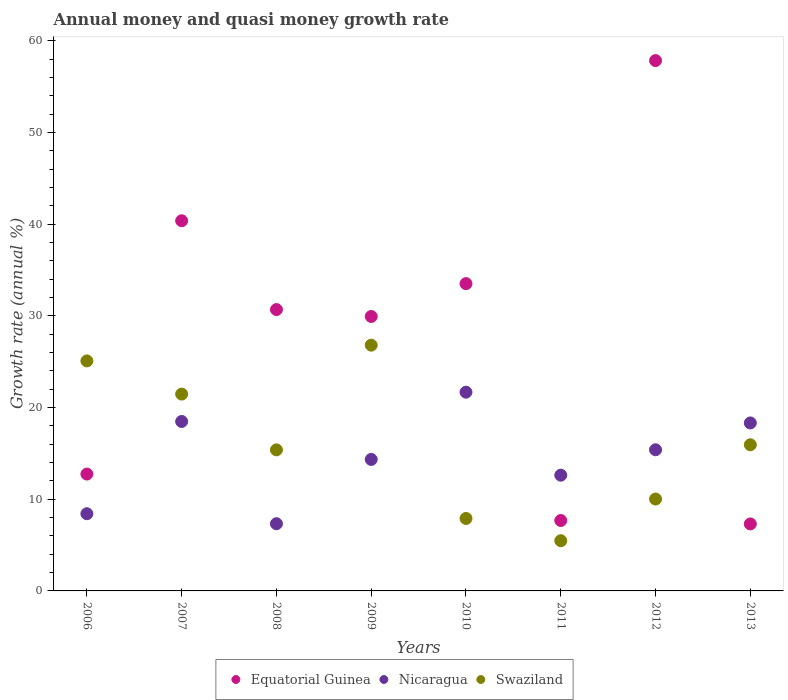What is the growth rate in Nicaragua in 2010?
Provide a short and direct response. 21.67. Across all years, what is the maximum growth rate in Swaziland?
Make the answer very short. 26.8. Across all years, what is the minimum growth rate in Equatorial Guinea?
Offer a terse response. 7.31. In which year was the growth rate in Swaziland maximum?
Your response must be concise. 2009. In which year was the growth rate in Swaziland minimum?
Give a very brief answer. 2011. What is the total growth rate in Nicaragua in the graph?
Offer a very short reply. 116.58. What is the difference between the growth rate in Equatorial Guinea in 2009 and that in 2012?
Give a very brief answer. -27.9. What is the difference between the growth rate in Nicaragua in 2006 and the growth rate in Equatorial Guinea in 2009?
Your answer should be compact. -21.51. What is the average growth rate in Equatorial Guinea per year?
Offer a terse response. 27.51. In the year 2012, what is the difference between the growth rate in Nicaragua and growth rate in Equatorial Guinea?
Provide a succinct answer. -42.44. What is the ratio of the growth rate in Nicaragua in 2006 to that in 2008?
Ensure brevity in your answer.  1.15. What is the difference between the highest and the second highest growth rate in Equatorial Guinea?
Offer a very short reply. 17.47. What is the difference between the highest and the lowest growth rate in Swaziland?
Provide a short and direct response. 21.33. Is it the case that in every year, the sum of the growth rate in Equatorial Guinea and growth rate in Nicaragua  is greater than the growth rate in Swaziland?
Offer a very short reply. No. Does the growth rate in Nicaragua monotonically increase over the years?
Offer a terse response. No. Is the growth rate in Equatorial Guinea strictly greater than the growth rate in Nicaragua over the years?
Provide a succinct answer. No. Is the growth rate in Equatorial Guinea strictly less than the growth rate in Swaziland over the years?
Provide a short and direct response. No. How many dotlines are there?
Offer a terse response. 3. How many years are there in the graph?
Provide a succinct answer. 8. What is the difference between two consecutive major ticks on the Y-axis?
Offer a very short reply. 10. Are the values on the major ticks of Y-axis written in scientific E-notation?
Ensure brevity in your answer.  No. How many legend labels are there?
Offer a very short reply. 3. How are the legend labels stacked?
Keep it short and to the point. Horizontal. What is the title of the graph?
Keep it short and to the point. Annual money and quasi money growth rate. Does "Low income" appear as one of the legend labels in the graph?
Keep it short and to the point. No. What is the label or title of the Y-axis?
Offer a terse response. Growth rate (annual %). What is the Growth rate (annual %) of Equatorial Guinea in 2006?
Your answer should be very brief. 12.74. What is the Growth rate (annual %) in Nicaragua in 2006?
Make the answer very short. 8.42. What is the Growth rate (annual %) of Swaziland in 2006?
Offer a very short reply. 25.08. What is the Growth rate (annual %) in Equatorial Guinea in 2007?
Provide a succinct answer. 40.37. What is the Growth rate (annual %) in Nicaragua in 2007?
Your answer should be compact. 18.48. What is the Growth rate (annual %) in Swaziland in 2007?
Your answer should be compact. 21.47. What is the Growth rate (annual %) of Equatorial Guinea in 2008?
Ensure brevity in your answer.  30.68. What is the Growth rate (annual %) of Nicaragua in 2008?
Give a very brief answer. 7.33. What is the Growth rate (annual %) of Swaziland in 2008?
Provide a short and direct response. 15.38. What is the Growth rate (annual %) of Equatorial Guinea in 2009?
Provide a short and direct response. 29.93. What is the Growth rate (annual %) of Nicaragua in 2009?
Give a very brief answer. 14.34. What is the Growth rate (annual %) in Swaziland in 2009?
Provide a short and direct response. 26.8. What is the Growth rate (annual %) of Equatorial Guinea in 2010?
Provide a short and direct response. 33.51. What is the Growth rate (annual %) of Nicaragua in 2010?
Ensure brevity in your answer.  21.67. What is the Growth rate (annual %) in Swaziland in 2010?
Ensure brevity in your answer.  7.9. What is the Growth rate (annual %) of Equatorial Guinea in 2011?
Ensure brevity in your answer.  7.68. What is the Growth rate (annual %) of Nicaragua in 2011?
Give a very brief answer. 12.62. What is the Growth rate (annual %) in Swaziland in 2011?
Your answer should be compact. 5.48. What is the Growth rate (annual %) in Equatorial Guinea in 2012?
Your answer should be compact. 57.83. What is the Growth rate (annual %) in Nicaragua in 2012?
Offer a very short reply. 15.39. What is the Growth rate (annual %) in Swaziland in 2012?
Make the answer very short. 10.02. What is the Growth rate (annual %) in Equatorial Guinea in 2013?
Your response must be concise. 7.31. What is the Growth rate (annual %) in Nicaragua in 2013?
Your response must be concise. 18.32. What is the Growth rate (annual %) in Swaziland in 2013?
Your answer should be compact. 15.94. Across all years, what is the maximum Growth rate (annual %) of Equatorial Guinea?
Ensure brevity in your answer.  57.83. Across all years, what is the maximum Growth rate (annual %) of Nicaragua?
Your answer should be compact. 21.67. Across all years, what is the maximum Growth rate (annual %) in Swaziland?
Keep it short and to the point. 26.8. Across all years, what is the minimum Growth rate (annual %) of Equatorial Guinea?
Keep it short and to the point. 7.31. Across all years, what is the minimum Growth rate (annual %) in Nicaragua?
Provide a succinct answer. 7.33. Across all years, what is the minimum Growth rate (annual %) in Swaziland?
Offer a terse response. 5.48. What is the total Growth rate (annual %) of Equatorial Guinea in the graph?
Keep it short and to the point. 220.05. What is the total Growth rate (annual %) of Nicaragua in the graph?
Ensure brevity in your answer.  116.58. What is the total Growth rate (annual %) of Swaziland in the graph?
Provide a short and direct response. 128.06. What is the difference between the Growth rate (annual %) in Equatorial Guinea in 2006 and that in 2007?
Make the answer very short. -27.62. What is the difference between the Growth rate (annual %) in Nicaragua in 2006 and that in 2007?
Your answer should be very brief. -10.06. What is the difference between the Growth rate (annual %) in Swaziland in 2006 and that in 2007?
Make the answer very short. 3.62. What is the difference between the Growth rate (annual %) of Equatorial Guinea in 2006 and that in 2008?
Make the answer very short. -17.94. What is the difference between the Growth rate (annual %) in Nicaragua in 2006 and that in 2008?
Provide a short and direct response. 1.09. What is the difference between the Growth rate (annual %) in Swaziland in 2006 and that in 2008?
Ensure brevity in your answer.  9.7. What is the difference between the Growth rate (annual %) in Equatorial Guinea in 2006 and that in 2009?
Ensure brevity in your answer.  -17.19. What is the difference between the Growth rate (annual %) of Nicaragua in 2006 and that in 2009?
Provide a short and direct response. -5.92. What is the difference between the Growth rate (annual %) of Swaziland in 2006 and that in 2009?
Your response must be concise. -1.72. What is the difference between the Growth rate (annual %) in Equatorial Guinea in 2006 and that in 2010?
Make the answer very short. -20.77. What is the difference between the Growth rate (annual %) of Nicaragua in 2006 and that in 2010?
Offer a very short reply. -13.25. What is the difference between the Growth rate (annual %) of Swaziland in 2006 and that in 2010?
Provide a succinct answer. 17.18. What is the difference between the Growth rate (annual %) in Equatorial Guinea in 2006 and that in 2011?
Offer a terse response. 5.06. What is the difference between the Growth rate (annual %) of Nicaragua in 2006 and that in 2011?
Ensure brevity in your answer.  -4.2. What is the difference between the Growth rate (annual %) of Swaziland in 2006 and that in 2011?
Provide a short and direct response. 19.61. What is the difference between the Growth rate (annual %) of Equatorial Guinea in 2006 and that in 2012?
Give a very brief answer. -45.09. What is the difference between the Growth rate (annual %) in Nicaragua in 2006 and that in 2012?
Give a very brief answer. -6.97. What is the difference between the Growth rate (annual %) of Swaziland in 2006 and that in 2012?
Provide a succinct answer. 15.07. What is the difference between the Growth rate (annual %) of Equatorial Guinea in 2006 and that in 2013?
Your response must be concise. 5.44. What is the difference between the Growth rate (annual %) of Nicaragua in 2006 and that in 2013?
Give a very brief answer. -9.9. What is the difference between the Growth rate (annual %) in Swaziland in 2006 and that in 2013?
Keep it short and to the point. 9.15. What is the difference between the Growth rate (annual %) of Equatorial Guinea in 2007 and that in 2008?
Offer a very short reply. 9.69. What is the difference between the Growth rate (annual %) in Nicaragua in 2007 and that in 2008?
Provide a succinct answer. 11.15. What is the difference between the Growth rate (annual %) in Swaziland in 2007 and that in 2008?
Offer a very short reply. 6.08. What is the difference between the Growth rate (annual %) in Equatorial Guinea in 2007 and that in 2009?
Keep it short and to the point. 10.44. What is the difference between the Growth rate (annual %) in Nicaragua in 2007 and that in 2009?
Offer a terse response. 4.14. What is the difference between the Growth rate (annual %) of Swaziland in 2007 and that in 2009?
Keep it short and to the point. -5.34. What is the difference between the Growth rate (annual %) in Equatorial Guinea in 2007 and that in 2010?
Keep it short and to the point. 6.86. What is the difference between the Growth rate (annual %) in Nicaragua in 2007 and that in 2010?
Offer a terse response. -3.19. What is the difference between the Growth rate (annual %) of Swaziland in 2007 and that in 2010?
Offer a very short reply. 13.56. What is the difference between the Growth rate (annual %) in Equatorial Guinea in 2007 and that in 2011?
Give a very brief answer. 32.69. What is the difference between the Growth rate (annual %) in Nicaragua in 2007 and that in 2011?
Your answer should be very brief. 5.86. What is the difference between the Growth rate (annual %) in Swaziland in 2007 and that in 2011?
Provide a succinct answer. 15.99. What is the difference between the Growth rate (annual %) of Equatorial Guinea in 2007 and that in 2012?
Your answer should be very brief. -17.47. What is the difference between the Growth rate (annual %) of Nicaragua in 2007 and that in 2012?
Give a very brief answer. 3.09. What is the difference between the Growth rate (annual %) in Swaziland in 2007 and that in 2012?
Your answer should be compact. 11.45. What is the difference between the Growth rate (annual %) of Equatorial Guinea in 2007 and that in 2013?
Make the answer very short. 33.06. What is the difference between the Growth rate (annual %) in Nicaragua in 2007 and that in 2013?
Provide a short and direct response. 0.16. What is the difference between the Growth rate (annual %) in Swaziland in 2007 and that in 2013?
Your answer should be very brief. 5.53. What is the difference between the Growth rate (annual %) in Equatorial Guinea in 2008 and that in 2009?
Ensure brevity in your answer.  0.75. What is the difference between the Growth rate (annual %) of Nicaragua in 2008 and that in 2009?
Offer a very short reply. -7.01. What is the difference between the Growth rate (annual %) in Swaziland in 2008 and that in 2009?
Provide a succinct answer. -11.42. What is the difference between the Growth rate (annual %) in Equatorial Guinea in 2008 and that in 2010?
Offer a terse response. -2.83. What is the difference between the Growth rate (annual %) of Nicaragua in 2008 and that in 2010?
Give a very brief answer. -14.34. What is the difference between the Growth rate (annual %) in Swaziland in 2008 and that in 2010?
Provide a succinct answer. 7.48. What is the difference between the Growth rate (annual %) in Equatorial Guinea in 2008 and that in 2011?
Provide a succinct answer. 23. What is the difference between the Growth rate (annual %) of Nicaragua in 2008 and that in 2011?
Provide a short and direct response. -5.29. What is the difference between the Growth rate (annual %) in Swaziland in 2008 and that in 2011?
Your answer should be compact. 9.91. What is the difference between the Growth rate (annual %) of Equatorial Guinea in 2008 and that in 2012?
Your answer should be compact. -27.15. What is the difference between the Growth rate (annual %) in Nicaragua in 2008 and that in 2012?
Provide a short and direct response. -8.06. What is the difference between the Growth rate (annual %) in Swaziland in 2008 and that in 2012?
Your response must be concise. 5.37. What is the difference between the Growth rate (annual %) of Equatorial Guinea in 2008 and that in 2013?
Your answer should be compact. 23.37. What is the difference between the Growth rate (annual %) in Nicaragua in 2008 and that in 2013?
Give a very brief answer. -10.99. What is the difference between the Growth rate (annual %) of Swaziland in 2008 and that in 2013?
Ensure brevity in your answer.  -0.55. What is the difference between the Growth rate (annual %) of Equatorial Guinea in 2009 and that in 2010?
Give a very brief answer. -3.58. What is the difference between the Growth rate (annual %) of Nicaragua in 2009 and that in 2010?
Offer a terse response. -7.33. What is the difference between the Growth rate (annual %) in Swaziland in 2009 and that in 2010?
Make the answer very short. 18.9. What is the difference between the Growth rate (annual %) in Equatorial Guinea in 2009 and that in 2011?
Your response must be concise. 22.25. What is the difference between the Growth rate (annual %) of Nicaragua in 2009 and that in 2011?
Give a very brief answer. 1.72. What is the difference between the Growth rate (annual %) in Swaziland in 2009 and that in 2011?
Your answer should be very brief. 21.33. What is the difference between the Growth rate (annual %) of Equatorial Guinea in 2009 and that in 2012?
Make the answer very short. -27.9. What is the difference between the Growth rate (annual %) of Nicaragua in 2009 and that in 2012?
Give a very brief answer. -1.05. What is the difference between the Growth rate (annual %) in Swaziland in 2009 and that in 2012?
Give a very brief answer. 16.78. What is the difference between the Growth rate (annual %) of Equatorial Guinea in 2009 and that in 2013?
Make the answer very short. 22.62. What is the difference between the Growth rate (annual %) in Nicaragua in 2009 and that in 2013?
Keep it short and to the point. -3.98. What is the difference between the Growth rate (annual %) of Swaziland in 2009 and that in 2013?
Your answer should be compact. 10.86. What is the difference between the Growth rate (annual %) of Equatorial Guinea in 2010 and that in 2011?
Offer a terse response. 25.83. What is the difference between the Growth rate (annual %) in Nicaragua in 2010 and that in 2011?
Provide a short and direct response. 9.05. What is the difference between the Growth rate (annual %) in Swaziland in 2010 and that in 2011?
Your answer should be compact. 2.43. What is the difference between the Growth rate (annual %) of Equatorial Guinea in 2010 and that in 2012?
Your response must be concise. -24.32. What is the difference between the Growth rate (annual %) in Nicaragua in 2010 and that in 2012?
Your answer should be compact. 6.28. What is the difference between the Growth rate (annual %) of Swaziland in 2010 and that in 2012?
Ensure brevity in your answer.  -2.12. What is the difference between the Growth rate (annual %) of Equatorial Guinea in 2010 and that in 2013?
Offer a terse response. 26.2. What is the difference between the Growth rate (annual %) of Nicaragua in 2010 and that in 2013?
Offer a terse response. 3.35. What is the difference between the Growth rate (annual %) of Swaziland in 2010 and that in 2013?
Ensure brevity in your answer.  -8.03. What is the difference between the Growth rate (annual %) of Equatorial Guinea in 2011 and that in 2012?
Give a very brief answer. -50.15. What is the difference between the Growth rate (annual %) in Nicaragua in 2011 and that in 2012?
Your answer should be compact. -2.77. What is the difference between the Growth rate (annual %) of Swaziland in 2011 and that in 2012?
Your answer should be compact. -4.54. What is the difference between the Growth rate (annual %) of Equatorial Guinea in 2011 and that in 2013?
Your answer should be very brief. 0.37. What is the difference between the Growth rate (annual %) in Nicaragua in 2011 and that in 2013?
Your answer should be very brief. -5.7. What is the difference between the Growth rate (annual %) in Swaziland in 2011 and that in 2013?
Your answer should be very brief. -10.46. What is the difference between the Growth rate (annual %) of Equatorial Guinea in 2012 and that in 2013?
Keep it short and to the point. 50.53. What is the difference between the Growth rate (annual %) in Nicaragua in 2012 and that in 2013?
Keep it short and to the point. -2.93. What is the difference between the Growth rate (annual %) in Swaziland in 2012 and that in 2013?
Offer a very short reply. -5.92. What is the difference between the Growth rate (annual %) of Equatorial Guinea in 2006 and the Growth rate (annual %) of Nicaragua in 2007?
Your response must be concise. -5.74. What is the difference between the Growth rate (annual %) of Equatorial Guinea in 2006 and the Growth rate (annual %) of Swaziland in 2007?
Give a very brief answer. -8.72. What is the difference between the Growth rate (annual %) in Nicaragua in 2006 and the Growth rate (annual %) in Swaziland in 2007?
Your answer should be compact. -13.05. What is the difference between the Growth rate (annual %) of Equatorial Guinea in 2006 and the Growth rate (annual %) of Nicaragua in 2008?
Make the answer very short. 5.41. What is the difference between the Growth rate (annual %) in Equatorial Guinea in 2006 and the Growth rate (annual %) in Swaziland in 2008?
Ensure brevity in your answer.  -2.64. What is the difference between the Growth rate (annual %) of Nicaragua in 2006 and the Growth rate (annual %) of Swaziland in 2008?
Your answer should be compact. -6.96. What is the difference between the Growth rate (annual %) of Equatorial Guinea in 2006 and the Growth rate (annual %) of Nicaragua in 2009?
Keep it short and to the point. -1.59. What is the difference between the Growth rate (annual %) in Equatorial Guinea in 2006 and the Growth rate (annual %) in Swaziland in 2009?
Your answer should be very brief. -14.06. What is the difference between the Growth rate (annual %) in Nicaragua in 2006 and the Growth rate (annual %) in Swaziland in 2009?
Keep it short and to the point. -18.38. What is the difference between the Growth rate (annual %) of Equatorial Guinea in 2006 and the Growth rate (annual %) of Nicaragua in 2010?
Provide a succinct answer. -8.93. What is the difference between the Growth rate (annual %) in Equatorial Guinea in 2006 and the Growth rate (annual %) in Swaziland in 2010?
Ensure brevity in your answer.  4.84. What is the difference between the Growth rate (annual %) in Nicaragua in 2006 and the Growth rate (annual %) in Swaziland in 2010?
Ensure brevity in your answer.  0.52. What is the difference between the Growth rate (annual %) of Equatorial Guinea in 2006 and the Growth rate (annual %) of Nicaragua in 2011?
Your answer should be compact. 0.12. What is the difference between the Growth rate (annual %) of Equatorial Guinea in 2006 and the Growth rate (annual %) of Swaziland in 2011?
Your answer should be very brief. 7.27. What is the difference between the Growth rate (annual %) in Nicaragua in 2006 and the Growth rate (annual %) in Swaziland in 2011?
Provide a short and direct response. 2.95. What is the difference between the Growth rate (annual %) in Equatorial Guinea in 2006 and the Growth rate (annual %) in Nicaragua in 2012?
Provide a succinct answer. -2.65. What is the difference between the Growth rate (annual %) of Equatorial Guinea in 2006 and the Growth rate (annual %) of Swaziland in 2012?
Provide a short and direct response. 2.73. What is the difference between the Growth rate (annual %) in Nicaragua in 2006 and the Growth rate (annual %) in Swaziland in 2012?
Keep it short and to the point. -1.6. What is the difference between the Growth rate (annual %) in Equatorial Guinea in 2006 and the Growth rate (annual %) in Nicaragua in 2013?
Keep it short and to the point. -5.58. What is the difference between the Growth rate (annual %) in Equatorial Guinea in 2006 and the Growth rate (annual %) in Swaziland in 2013?
Provide a short and direct response. -3.19. What is the difference between the Growth rate (annual %) of Nicaragua in 2006 and the Growth rate (annual %) of Swaziland in 2013?
Your answer should be very brief. -7.52. What is the difference between the Growth rate (annual %) in Equatorial Guinea in 2007 and the Growth rate (annual %) in Nicaragua in 2008?
Your answer should be compact. 33.04. What is the difference between the Growth rate (annual %) of Equatorial Guinea in 2007 and the Growth rate (annual %) of Swaziland in 2008?
Give a very brief answer. 24.98. What is the difference between the Growth rate (annual %) of Nicaragua in 2007 and the Growth rate (annual %) of Swaziland in 2008?
Ensure brevity in your answer.  3.1. What is the difference between the Growth rate (annual %) of Equatorial Guinea in 2007 and the Growth rate (annual %) of Nicaragua in 2009?
Provide a succinct answer. 26.03. What is the difference between the Growth rate (annual %) in Equatorial Guinea in 2007 and the Growth rate (annual %) in Swaziland in 2009?
Make the answer very short. 13.57. What is the difference between the Growth rate (annual %) of Nicaragua in 2007 and the Growth rate (annual %) of Swaziland in 2009?
Keep it short and to the point. -8.32. What is the difference between the Growth rate (annual %) in Equatorial Guinea in 2007 and the Growth rate (annual %) in Nicaragua in 2010?
Provide a succinct answer. 18.69. What is the difference between the Growth rate (annual %) in Equatorial Guinea in 2007 and the Growth rate (annual %) in Swaziland in 2010?
Ensure brevity in your answer.  32.47. What is the difference between the Growth rate (annual %) in Nicaragua in 2007 and the Growth rate (annual %) in Swaziland in 2010?
Keep it short and to the point. 10.58. What is the difference between the Growth rate (annual %) in Equatorial Guinea in 2007 and the Growth rate (annual %) in Nicaragua in 2011?
Provide a short and direct response. 27.75. What is the difference between the Growth rate (annual %) in Equatorial Guinea in 2007 and the Growth rate (annual %) in Swaziland in 2011?
Your answer should be very brief. 34.89. What is the difference between the Growth rate (annual %) of Nicaragua in 2007 and the Growth rate (annual %) of Swaziland in 2011?
Your answer should be very brief. 13. What is the difference between the Growth rate (annual %) in Equatorial Guinea in 2007 and the Growth rate (annual %) in Nicaragua in 2012?
Your response must be concise. 24.97. What is the difference between the Growth rate (annual %) of Equatorial Guinea in 2007 and the Growth rate (annual %) of Swaziland in 2012?
Provide a short and direct response. 30.35. What is the difference between the Growth rate (annual %) in Nicaragua in 2007 and the Growth rate (annual %) in Swaziland in 2012?
Your answer should be very brief. 8.46. What is the difference between the Growth rate (annual %) in Equatorial Guinea in 2007 and the Growth rate (annual %) in Nicaragua in 2013?
Make the answer very short. 22.05. What is the difference between the Growth rate (annual %) of Equatorial Guinea in 2007 and the Growth rate (annual %) of Swaziland in 2013?
Keep it short and to the point. 24.43. What is the difference between the Growth rate (annual %) of Nicaragua in 2007 and the Growth rate (annual %) of Swaziland in 2013?
Keep it short and to the point. 2.54. What is the difference between the Growth rate (annual %) in Equatorial Guinea in 2008 and the Growth rate (annual %) in Nicaragua in 2009?
Make the answer very short. 16.34. What is the difference between the Growth rate (annual %) of Equatorial Guinea in 2008 and the Growth rate (annual %) of Swaziland in 2009?
Offer a terse response. 3.88. What is the difference between the Growth rate (annual %) of Nicaragua in 2008 and the Growth rate (annual %) of Swaziland in 2009?
Give a very brief answer. -19.47. What is the difference between the Growth rate (annual %) in Equatorial Guinea in 2008 and the Growth rate (annual %) in Nicaragua in 2010?
Provide a succinct answer. 9.01. What is the difference between the Growth rate (annual %) in Equatorial Guinea in 2008 and the Growth rate (annual %) in Swaziland in 2010?
Provide a succinct answer. 22.78. What is the difference between the Growth rate (annual %) of Nicaragua in 2008 and the Growth rate (annual %) of Swaziland in 2010?
Keep it short and to the point. -0.57. What is the difference between the Growth rate (annual %) of Equatorial Guinea in 2008 and the Growth rate (annual %) of Nicaragua in 2011?
Your answer should be very brief. 18.06. What is the difference between the Growth rate (annual %) of Equatorial Guinea in 2008 and the Growth rate (annual %) of Swaziland in 2011?
Ensure brevity in your answer.  25.2. What is the difference between the Growth rate (annual %) of Nicaragua in 2008 and the Growth rate (annual %) of Swaziland in 2011?
Offer a terse response. 1.85. What is the difference between the Growth rate (annual %) of Equatorial Guinea in 2008 and the Growth rate (annual %) of Nicaragua in 2012?
Keep it short and to the point. 15.29. What is the difference between the Growth rate (annual %) of Equatorial Guinea in 2008 and the Growth rate (annual %) of Swaziland in 2012?
Your answer should be compact. 20.66. What is the difference between the Growth rate (annual %) in Nicaragua in 2008 and the Growth rate (annual %) in Swaziland in 2012?
Give a very brief answer. -2.69. What is the difference between the Growth rate (annual %) in Equatorial Guinea in 2008 and the Growth rate (annual %) in Nicaragua in 2013?
Ensure brevity in your answer.  12.36. What is the difference between the Growth rate (annual %) of Equatorial Guinea in 2008 and the Growth rate (annual %) of Swaziland in 2013?
Offer a terse response. 14.74. What is the difference between the Growth rate (annual %) of Nicaragua in 2008 and the Growth rate (annual %) of Swaziland in 2013?
Make the answer very short. -8.61. What is the difference between the Growth rate (annual %) in Equatorial Guinea in 2009 and the Growth rate (annual %) in Nicaragua in 2010?
Ensure brevity in your answer.  8.26. What is the difference between the Growth rate (annual %) in Equatorial Guinea in 2009 and the Growth rate (annual %) in Swaziland in 2010?
Keep it short and to the point. 22.03. What is the difference between the Growth rate (annual %) of Nicaragua in 2009 and the Growth rate (annual %) of Swaziland in 2010?
Make the answer very short. 6.44. What is the difference between the Growth rate (annual %) of Equatorial Guinea in 2009 and the Growth rate (annual %) of Nicaragua in 2011?
Offer a terse response. 17.31. What is the difference between the Growth rate (annual %) in Equatorial Guinea in 2009 and the Growth rate (annual %) in Swaziland in 2011?
Give a very brief answer. 24.45. What is the difference between the Growth rate (annual %) in Nicaragua in 2009 and the Growth rate (annual %) in Swaziland in 2011?
Provide a short and direct response. 8.86. What is the difference between the Growth rate (annual %) of Equatorial Guinea in 2009 and the Growth rate (annual %) of Nicaragua in 2012?
Ensure brevity in your answer.  14.54. What is the difference between the Growth rate (annual %) in Equatorial Guinea in 2009 and the Growth rate (annual %) in Swaziland in 2012?
Your answer should be compact. 19.91. What is the difference between the Growth rate (annual %) in Nicaragua in 2009 and the Growth rate (annual %) in Swaziland in 2012?
Ensure brevity in your answer.  4.32. What is the difference between the Growth rate (annual %) in Equatorial Guinea in 2009 and the Growth rate (annual %) in Nicaragua in 2013?
Provide a succinct answer. 11.61. What is the difference between the Growth rate (annual %) of Equatorial Guinea in 2009 and the Growth rate (annual %) of Swaziland in 2013?
Keep it short and to the point. 13.99. What is the difference between the Growth rate (annual %) of Nicaragua in 2009 and the Growth rate (annual %) of Swaziland in 2013?
Your response must be concise. -1.6. What is the difference between the Growth rate (annual %) of Equatorial Guinea in 2010 and the Growth rate (annual %) of Nicaragua in 2011?
Give a very brief answer. 20.89. What is the difference between the Growth rate (annual %) in Equatorial Guinea in 2010 and the Growth rate (annual %) in Swaziland in 2011?
Offer a very short reply. 28.04. What is the difference between the Growth rate (annual %) in Nicaragua in 2010 and the Growth rate (annual %) in Swaziland in 2011?
Make the answer very short. 16.2. What is the difference between the Growth rate (annual %) of Equatorial Guinea in 2010 and the Growth rate (annual %) of Nicaragua in 2012?
Offer a very short reply. 18.12. What is the difference between the Growth rate (annual %) of Equatorial Guinea in 2010 and the Growth rate (annual %) of Swaziland in 2012?
Your response must be concise. 23.49. What is the difference between the Growth rate (annual %) of Nicaragua in 2010 and the Growth rate (annual %) of Swaziland in 2012?
Your answer should be very brief. 11.66. What is the difference between the Growth rate (annual %) in Equatorial Guinea in 2010 and the Growth rate (annual %) in Nicaragua in 2013?
Your answer should be compact. 15.19. What is the difference between the Growth rate (annual %) in Equatorial Guinea in 2010 and the Growth rate (annual %) in Swaziland in 2013?
Make the answer very short. 17.57. What is the difference between the Growth rate (annual %) of Nicaragua in 2010 and the Growth rate (annual %) of Swaziland in 2013?
Offer a terse response. 5.74. What is the difference between the Growth rate (annual %) of Equatorial Guinea in 2011 and the Growth rate (annual %) of Nicaragua in 2012?
Provide a short and direct response. -7.71. What is the difference between the Growth rate (annual %) of Equatorial Guinea in 2011 and the Growth rate (annual %) of Swaziland in 2012?
Your answer should be compact. -2.34. What is the difference between the Growth rate (annual %) of Nicaragua in 2011 and the Growth rate (annual %) of Swaziland in 2012?
Make the answer very short. 2.6. What is the difference between the Growth rate (annual %) of Equatorial Guinea in 2011 and the Growth rate (annual %) of Nicaragua in 2013?
Offer a very short reply. -10.64. What is the difference between the Growth rate (annual %) in Equatorial Guinea in 2011 and the Growth rate (annual %) in Swaziland in 2013?
Your response must be concise. -8.26. What is the difference between the Growth rate (annual %) of Nicaragua in 2011 and the Growth rate (annual %) of Swaziland in 2013?
Offer a very short reply. -3.31. What is the difference between the Growth rate (annual %) of Equatorial Guinea in 2012 and the Growth rate (annual %) of Nicaragua in 2013?
Keep it short and to the point. 39.51. What is the difference between the Growth rate (annual %) in Equatorial Guinea in 2012 and the Growth rate (annual %) in Swaziland in 2013?
Provide a succinct answer. 41.9. What is the difference between the Growth rate (annual %) of Nicaragua in 2012 and the Growth rate (annual %) of Swaziland in 2013?
Your answer should be compact. -0.54. What is the average Growth rate (annual %) of Equatorial Guinea per year?
Give a very brief answer. 27.51. What is the average Growth rate (annual %) of Nicaragua per year?
Offer a terse response. 14.57. What is the average Growth rate (annual %) of Swaziland per year?
Keep it short and to the point. 16.01. In the year 2006, what is the difference between the Growth rate (annual %) in Equatorial Guinea and Growth rate (annual %) in Nicaragua?
Give a very brief answer. 4.32. In the year 2006, what is the difference between the Growth rate (annual %) in Equatorial Guinea and Growth rate (annual %) in Swaziland?
Offer a terse response. -12.34. In the year 2006, what is the difference between the Growth rate (annual %) of Nicaragua and Growth rate (annual %) of Swaziland?
Provide a short and direct response. -16.66. In the year 2007, what is the difference between the Growth rate (annual %) of Equatorial Guinea and Growth rate (annual %) of Nicaragua?
Your answer should be compact. 21.89. In the year 2007, what is the difference between the Growth rate (annual %) of Equatorial Guinea and Growth rate (annual %) of Swaziland?
Provide a succinct answer. 18.9. In the year 2007, what is the difference between the Growth rate (annual %) of Nicaragua and Growth rate (annual %) of Swaziland?
Your response must be concise. -2.99. In the year 2008, what is the difference between the Growth rate (annual %) of Equatorial Guinea and Growth rate (annual %) of Nicaragua?
Provide a succinct answer. 23.35. In the year 2008, what is the difference between the Growth rate (annual %) in Equatorial Guinea and Growth rate (annual %) in Swaziland?
Offer a very short reply. 15.3. In the year 2008, what is the difference between the Growth rate (annual %) in Nicaragua and Growth rate (annual %) in Swaziland?
Your response must be concise. -8.05. In the year 2009, what is the difference between the Growth rate (annual %) of Equatorial Guinea and Growth rate (annual %) of Nicaragua?
Ensure brevity in your answer.  15.59. In the year 2009, what is the difference between the Growth rate (annual %) in Equatorial Guinea and Growth rate (annual %) in Swaziland?
Ensure brevity in your answer.  3.13. In the year 2009, what is the difference between the Growth rate (annual %) in Nicaragua and Growth rate (annual %) in Swaziland?
Ensure brevity in your answer.  -12.46. In the year 2010, what is the difference between the Growth rate (annual %) of Equatorial Guinea and Growth rate (annual %) of Nicaragua?
Keep it short and to the point. 11.84. In the year 2010, what is the difference between the Growth rate (annual %) of Equatorial Guinea and Growth rate (annual %) of Swaziland?
Make the answer very short. 25.61. In the year 2010, what is the difference between the Growth rate (annual %) of Nicaragua and Growth rate (annual %) of Swaziland?
Make the answer very short. 13.77. In the year 2011, what is the difference between the Growth rate (annual %) in Equatorial Guinea and Growth rate (annual %) in Nicaragua?
Offer a terse response. -4.94. In the year 2011, what is the difference between the Growth rate (annual %) of Equatorial Guinea and Growth rate (annual %) of Swaziland?
Provide a short and direct response. 2.21. In the year 2011, what is the difference between the Growth rate (annual %) of Nicaragua and Growth rate (annual %) of Swaziland?
Your answer should be very brief. 7.15. In the year 2012, what is the difference between the Growth rate (annual %) in Equatorial Guinea and Growth rate (annual %) in Nicaragua?
Provide a succinct answer. 42.44. In the year 2012, what is the difference between the Growth rate (annual %) in Equatorial Guinea and Growth rate (annual %) in Swaziland?
Your response must be concise. 47.82. In the year 2012, what is the difference between the Growth rate (annual %) in Nicaragua and Growth rate (annual %) in Swaziland?
Give a very brief answer. 5.38. In the year 2013, what is the difference between the Growth rate (annual %) in Equatorial Guinea and Growth rate (annual %) in Nicaragua?
Make the answer very short. -11.01. In the year 2013, what is the difference between the Growth rate (annual %) of Equatorial Guinea and Growth rate (annual %) of Swaziland?
Keep it short and to the point. -8.63. In the year 2013, what is the difference between the Growth rate (annual %) in Nicaragua and Growth rate (annual %) in Swaziland?
Offer a terse response. 2.38. What is the ratio of the Growth rate (annual %) of Equatorial Guinea in 2006 to that in 2007?
Keep it short and to the point. 0.32. What is the ratio of the Growth rate (annual %) of Nicaragua in 2006 to that in 2007?
Give a very brief answer. 0.46. What is the ratio of the Growth rate (annual %) of Swaziland in 2006 to that in 2007?
Ensure brevity in your answer.  1.17. What is the ratio of the Growth rate (annual %) of Equatorial Guinea in 2006 to that in 2008?
Your response must be concise. 0.42. What is the ratio of the Growth rate (annual %) of Nicaragua in 2006 to that in 2008?
Keep it short and to the point. 1.15. What is the ratio of the Growth rate (annual %) of Swaziland in 2006 to that in 2008?
Your response must be concise. 1.63. What is the ratio of the Growth rate (annual %) of Equatorial Guinea in 2006 to that in 2009?
Ensure brevity in your answer.  0.43. What is the ratio of the Growth rate (annual %) in Nicaragua in 2006 to that in 2009?
Your response must be concise. 0.59. What is the ratio of the Growth rate (annual %) in Swaziland in 2006 to that in 2009?
Your answer should be very brief. 0.94. What is the ratio of the Growth rate (annual %) in Equatorial Guinea in 2006 to that in 2010?
Offer a very short reply. 0.38. What is the ratio of the Growth rate (annual %) of Nicaragua in 2006 to that in 2010?
Give a very brief answer. 0.39. What is the ratio of the Growth rate (annual %) of Swaziland in 2006 to that in 2010?
Offer a terse response. 3.17. What is the ratio of the Growth rate (annual %) of Equatorial Guinea in 2006 to that in 2011?
Keep it short and to the point. 1.66. What is the ratio of the Growth rate (annual %) in Nicaragua in 2006 to that in 2011?
Offer a terse response. 0.67. What is the ratio of the Growth rate (annual %) in Swaziland in 2006 to that in 2011?
Your answer should be very brief. 4.58. What is the ratio of the Growth rate (annual %) in Equatorial Guinea in 2006 to that in 2012?
Provide a succinct answer. 0.22. What is the ratio of the Growth rate (annual %) in Nicaragua in 2006 to that in 2012?
Provide a succinct answer. 0.55. What is the ratio of the Growth rate (annual %) in Swaziland in 2006 to that in 2012?
Give a very brief answer. 2.5. What is the ratio of the Growth rate (annual %) of Equatorial Guinea in 2006 to that in 2013?
Keep it short and to the point. 1.74. What is the ratio of the Growth rate (annual %) in Nicaragua in 2006 to that in 2013?
Provide a succinct answer. 0.46. What is the ratio of the Growth rate (annual %) of Swaziland in 2006 to that in 2013?
Offer a very short reply. 1.57. What is the ratio of the Growth rate (annual %) of Equatorial Guinea in 2007 to that in 2008?
Keep it short and to the point. 1.32. What is the ratio of the Growth rate (annual %) of Nicaragua in 2007 to that in 2008?
Ensure brevity in your answer.  2.52. What is the ratio of the Growth rate (annual %) in Swaziland in 2007 to that in 2008?
Your answer should be very brief. 1.4. What is the ratio of the Growth rate (annual %) of Equatorial Guinea in 2007 to that in 2009?
Your answer should be compact. 1.35. What is the ratio of the Growth rate (annual %) of Nicaragua in 2007 to that in 2009?
Your answer should be compact. 1.29. What is the ratio of the Growth rate (annual %) of Swaziland in 2007 to that in 2009?
Offer a terse response. 0.8. What is the ratio of the Growth rate (annual %) in Equatorial Guinea in 2007 to that in 2010?
Offer a terse response. 1.2. What is the ratio of the Growth rate (annual %) in Nicaragua in 2007 to that in 2010?
Offer a terse response. 0.85. What is the ratio of the Growth rate (annual %) in Swaziland in 2007 to that in 2010?
Your answer should be compact. 2.72. What is the ratio of the Growth rate (annual %) of Equatorial Guinea in 2007 to that in 2011?
Keep it short and to the point. 5.26. What is the ratio of the Growth rate (annual %) of Nicaragua in 2007 to that in 2011?
Provide a short and direct response. 1.46. What is the ratio of the Growth rate (annual %) in Swaziland in 2007 to that in 2011?
Provide a succinct answer. 3.92. What is the ratio of the Growth rate (annual %) of Equatorial Guinea in 2007 to that in 2012?
Your response must be concise. 0.7. What is the ratio of the Growth rate (annual %) in Nicaragua in 2007 to that in 2012?
Provide a succinct answer. 1.2. What is the ratio of the Growth rate (annual %) in Swaziland in 2007 to that in 2012?
Keep it short and to the point. 2.14. What is the ratio of the Growth rate (annual %) in Equatorial Guinea in 2007 to that in 2013?
Provide a short and direct response. 5.53. What is the ratio of the Growth rate (annual %) in Nicaragua in 2007 to that in 2013?
Provide a succinct answer. 1.01. What is the ratio of the Growth rate (annual %) in Swaziland in 2007 to that in 2013?
Provide a short and direct response. 1.35. What is the ratio of the Growth rate (annual %) of Equatorial Guinea in 2008 to that in 2009?
Offer a terse response. 1.02. What is the ratio of the Growth rate (annual %) in Nicaragua in 2008 to that in 2009?
Offer a terse response. 0.51. What is the ratio of the Growth rate (annual %) of Swaziland in 2008 to that in 2009?
Keep it short and to the point. 0.57. What is the ratio of the Growth rate (annual %) in Equatorial Guinea in 2008 to that in 2010?
Ensure brevity in your answer.  0.92. What is the ratio of the Growth rate (annual %) in Nicaragua in 2008 to that in 2010?
Your answer should be compact. 0.34. What is the ratio of the Growth rate (annual %) in Swaziland in 2008 to that in 2010?
Your answer should be compact. 1.95. What is the ratio of the Growth rate (annual %) of Equatorial Guinea in 2008 to that in 2011?
Give a very brief answer. 3.99. What is the ratio of the Growth rate (annual %) of Nicaragua in 2008 to that in 2011?
Keep it short and to the point. 0.58. What is the ratio of the Growth rate (annual %) of Swaziland in 2008 to that in 2011?
Your answer should be very brief. 2.81. What is the ratio of the Growth rate (annual %) in Equatorial Guinea in 2008 to that in 2012?
Your answer should be very brief. 0.53. What is the ratio of the Growth rate (annual %) of Nicaragua in 2008 to that in 2012?
Offer a terse response. 0.48. What is the ratio of the Growth rate (annual %) in Swaziland in 2008 to that in 2012?
Give a very brief answer. 1.54. What is the ratio of the Growth rate (annual %) in Equatorial Guinea in 2008 to that in 2013?
Give a very brief answer. 4.2. What is the ratio of the Growth rate (annual %) in Nicaragua in 2008 to that in 2013?
Your response must be concise. 0.4. What is the ratio of the Growth rate (annual %) in Swaziland in 2008 to that in 2013?
Offer a terse response. 0.97. What is the ratio of the Growth rate (annual %) in Equatorial Guinea in 2009 to that in 2010?
Provide a succinct answer. 0.89. What is the ratio of the Growth rate (annual %) in Nicaragua in 2009 to that in 2010?
Your answer should be compact. 0.66. What is the ratio of the Growth rate (annual %) in Swaziland in 2009 to that in 2010?
Ensure brevity in your answer.  3.39. What is the ratio of the Growth rate (annual %) in Equatorial Guinea in 2009 to that in 2011?
Provide a short and direct response. 3.9. What is the ratio of the Growth rate (annual %) in Nicaragua in 2009 to that in 2011?
Provide a succinct answer. 1.14. What is the ratio of the Growth rate (annual %) in Swaziland in 2009 to that in 2011?
Your response must be concise. 4.89. What is the ratio of the Growth rate (annual %) of Equatorial Guinea in 2009 to that in 2012?
Keep it short and to the point. 0.52. What is the ratio of the Growth rate (annual %) of Nicaragua in 2009 to that in 2012?
Keep it short and to the point. 0.93. What is the ratio of the Growth rate (annual %) of Swaziland in 2009 to that in 2012?
Give a very brief answer. 2.68. What is the ratio of the Growth rate (annual %) in Equatorial Guinea in 2009 to that in 2013?
Provide a short and direct response. 4.1. What is the ratio of the Growth rate (annual %) in Nicaragua in 2009 to that in 2013?
Offer a terse response. 0.78. What is the ratio of the Growth rate (annual %) of Swaziland in 2009 to that in 2013?
Offer a terse response. 1.68. What is the ratio of the Growth rate (annual %) in Equatorial Guinea in 2010 to that in 2011?
Offer a very short reply. 4.36. What is the ratio of the Growth rate (annual %) of Nicaragua in 2010 to that in 2011?
Provide a short and direct response. 1.72. What is the ratio of the Growth rate (annual %) in Swaziland in 2010 to that in 2011?
Make the answer very short. 1.44. What is the ratio of the Growth rate (annual %) in Equatorial Guinea in 2010 to that in 2012?
Keep it short and to the point. 0.58. What is the ratio of the Growth rate (annual %) in Nicaragua in 2010 to that in 2012?
Provide a succinct answer. 1.41. What is the ratio of the Growth rate (annual %) of Swaziland in 2010 to that in 2012?
Keep it short and to the point. 0.79. What is the ratio of the Growth rate (annual %) in Equatorial Guinea in 2010 to that in 2013?
Offer a terse response. 4.59. What is the ratio of the Growth rate (annual %) in Nicaragua in 2010 to that in 2013?
Provide a short and direct response. 1.18. What is the ratio of the Growth rate (annual %) of Swaziland in 2010 to that in 2013?
Offer a very short reply. 0.5. What is the ratio of the Growth rate (annual %) in Equatorial Guinea in 2011 to that in 2012?
Offer a very short reply. 0.13. What is the ratio of the Growth rate (annual %) of Nicaragua in 2011 to that in 2012?
Provide a short and direct response. 0.82. What is the ratio of the Growth rate (annual %) of Swaziland in 2011 to that in 2012?
Provide a short and direct response. 0.55. What is the ratio of the Growth rate (annual %) of Equatorial Guinea in 2011 to that in 2013?
Provide a short and direct response. 1.05. What is the ratio of the Growth rate (annual %) in Nicaragua in 2011 to that in 2013?
Keep it short and to the point. 0.69. What is the ratio of the Growth rate (annual %) of Swaziland in 2011 to that in 2013?
Keep it short and to the point. 0.34. What is the ratio of the Growth rate (annual %) in Equatorial Guinea in 2012 to that in 2013?
Provide a succinct answer. 7.92. What is the ratio of the Growth rate (annual %) of Nicaragua in 2012 to that in 2013?
Your answer should be compact. 0.84. What is the ratio of the Growth rate (annual %) in Swaziland in 2012 to that in 2013?
Your response must be concise. 0.63. What is the difference between the highest and the second highest Growth rate (annual %) in Equatorial Guinea?
Keep it short and to the point. 17.47. What is the difference between the highest and the second highest Growth rate (annual %) in Nicaragua?
Your response must be concise. 3.19. What is the difference between the highest and the second highest Growth rate (annual %) of Swaziland?
Give a very brief answer. 1.72. What is the difference between the highest and the lowest Growth rate (annual %) in Equatorial Guinea?
Your answer should be very brief. 50.53. What is the difference between the highest and the lowest Growth rate (annual %) of Nicaragua?
Your response must be concise. 14.34. What is the difference between the highest and the lowest Growth rate (annual %) in Swaziland?
Your answer should be compact. 21.33. 